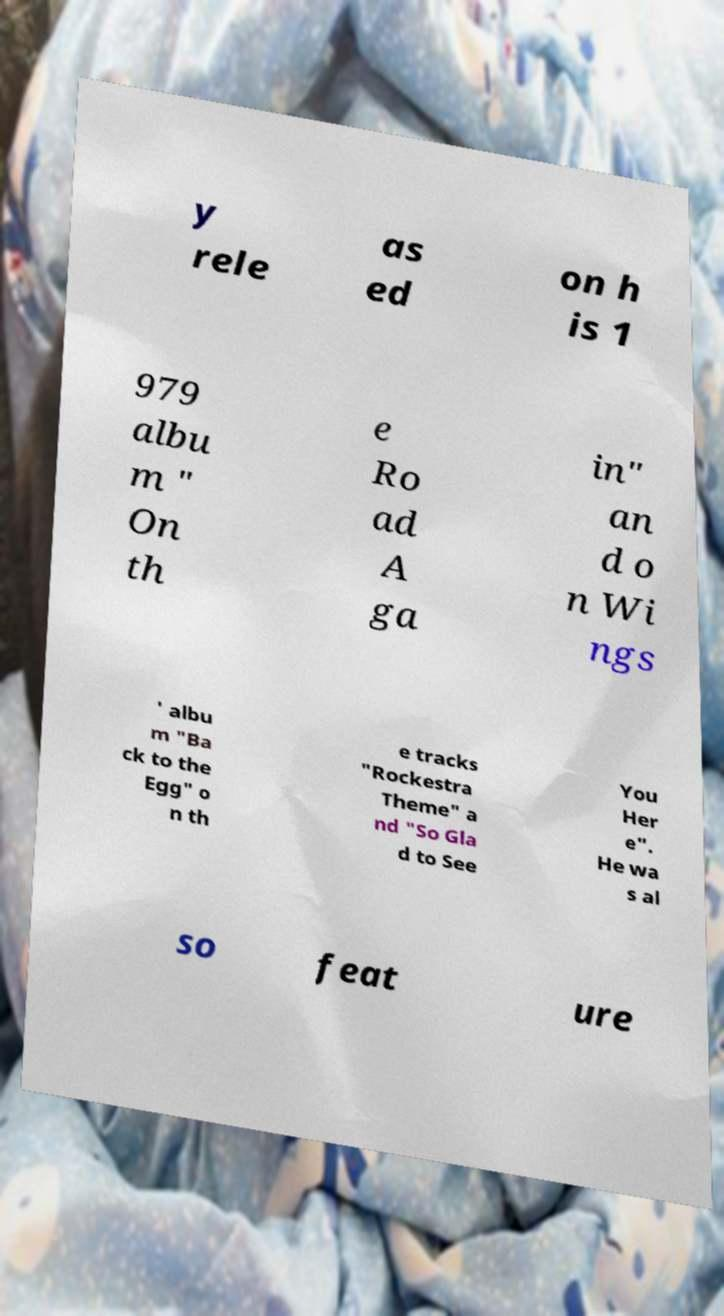For documentation purposes, I need the text within this image transcribed. Could you provide that? y rele as ed on h is 1 979 albu m " On th e Ro ad A ga in" an d o n Wi ngs ' albu m "Ba ck to the Egg" o n th e tracks "Rockestra Theme" a nd "So Gla d to See You Her e". He wa s al so feat ure 